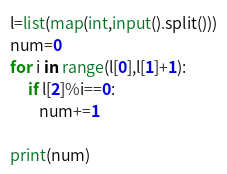<code> <loc_0><loc_0><loc_500><loc_500><_Python_>l=list(map(int,input().split()))
num=0
for i in range(l[0],l[1]+1):
	 if l[2]%i==0:
	 	num+=1
	 	
print(num)
</code> 